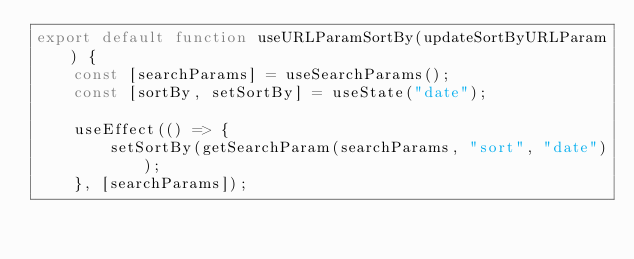Convert code to text. <code><loc_0><loc_0><loc_500><loc_500><_JavaScript_>export default function useURLParamSortBy(updateSortByURLParam) {
    const [searchParams] = useSearchParams();
    const [sortBy, setSortBy] = useState("date");

    useEffect(() => {
        setSortBy(getSearchParam(searchParams, "sort", "date"));
    }, [searchParams]);
</code> 